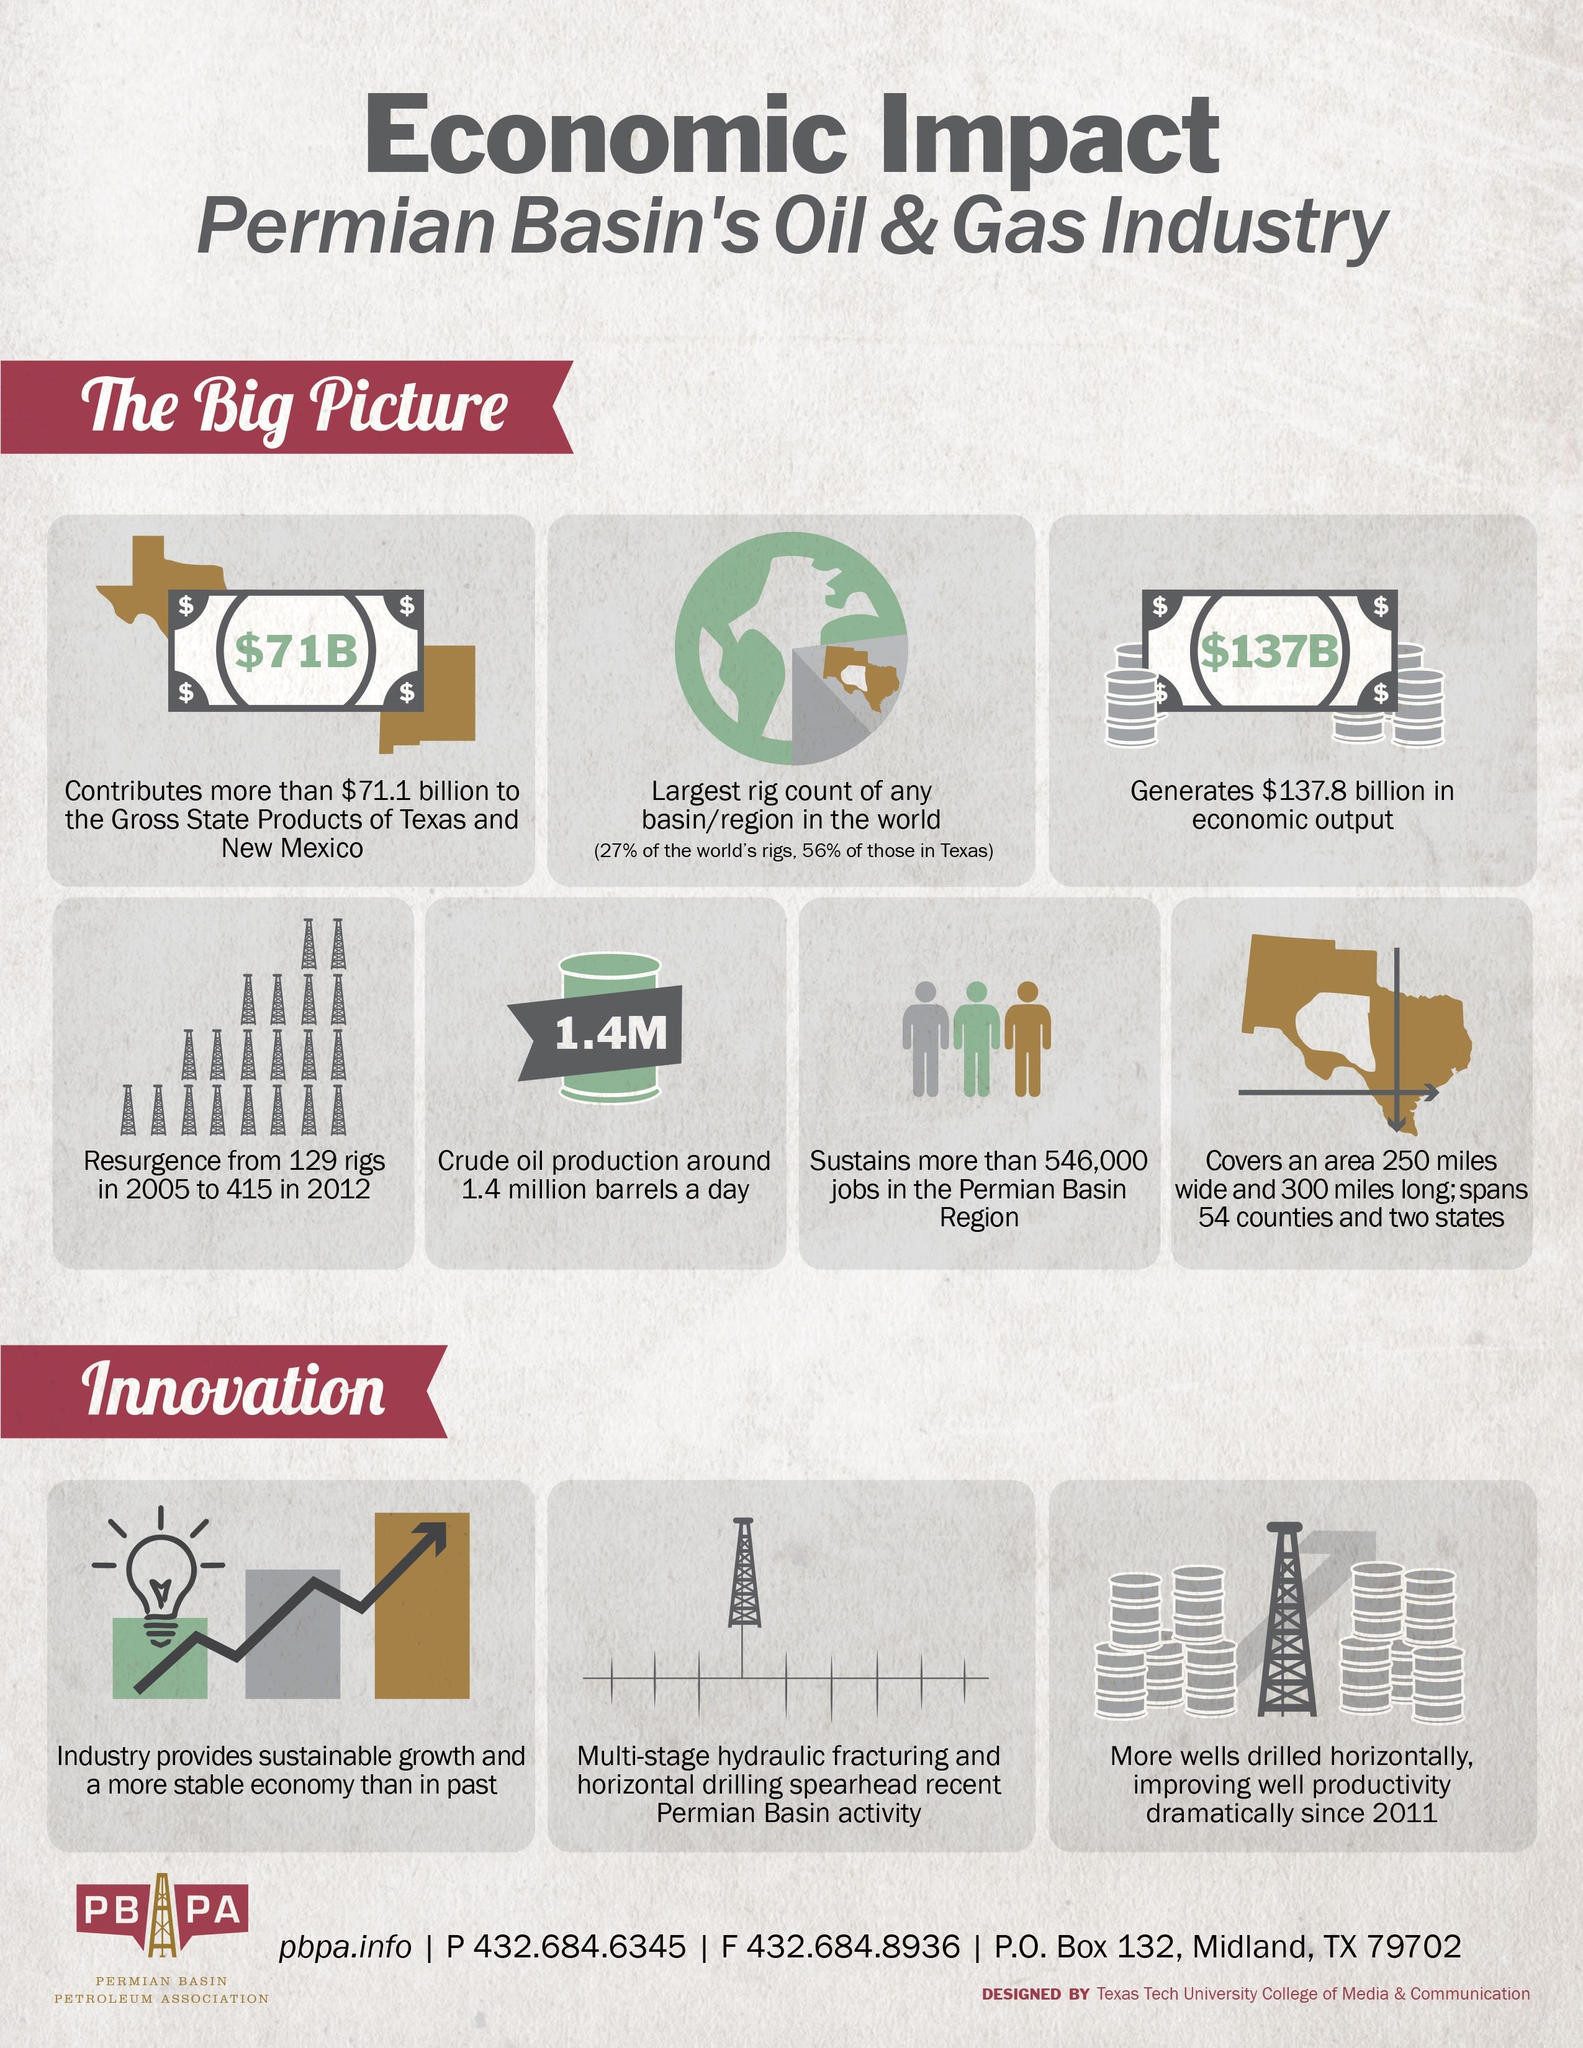Draw attention to some important aspects in this diagram. The Permian Basin's oil and gas industry covers a total area of approximately 75,000 square miles. During the period from 2005 to 2012, there was a significant increase in the number of rigs in operation, with a resurgence of 286 rigs. 